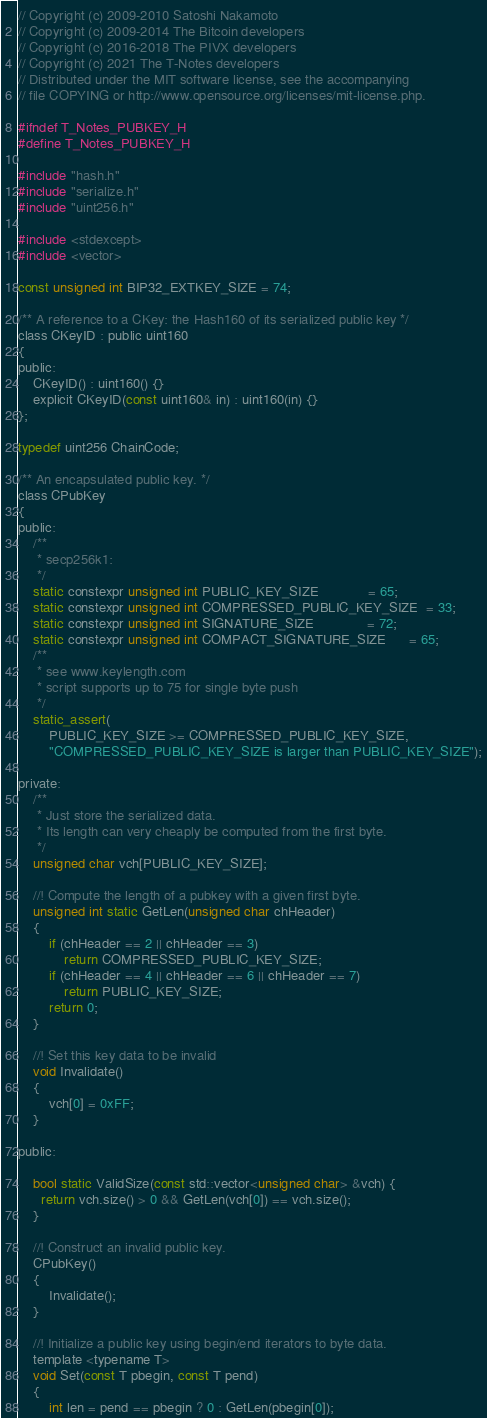<code> <loc_0><loc_0><loc_500><loc_500><_C_>// Copyright (c) 2009-2010 Satoshi Nakamoto
// Copyright (c) 2009-2014 The Bitcoin developers
// Copyright (c) 2016-2018 The PIVX developers
// Copyright (c) 2021 The T-Notes developers
// Distributed under the MIT software license, see the accompanying
// file COPYING or http://www.opensource.org/licenses/mit-license.php.

#ifndef T_Notes_PUBKEY_H
#define T_Notes_PUBKEY_H

#include "hash.h"
#include "serialize.h"
#include "uint256.h"

#include <stdexcept>
#include <vector>

const unsigned int BIP32_EXTKEY_SIZE = 74;

/** A reference to a CKey: the Hash160 of its serialized public key */
class CKeyID : public uint160
{
public:
    CKeyID() : uint160() {}
    explicit CKeyID(const uint160& in) : uint160(in) {}
};

typedef uint256 ChainCode;

/** An encapsulated public key. */
class CPubKey
{
public:
    /**
     * secp256k1:
     */
    static constexpr unsigned int PUBLIC_KEY_SIZE             = 65;
    static constexpr unsigned int COMPRESSED_PUBLIC_KEY_SIZE  = 33;
    static constexpr unsigned int SIGNATURE_SIZE              = 72;
    static constexpr unsigned int COMPACT_SIGNATURE_SIZE      = 65;
    /**
     * see www.keylength.com
     * script supports up to 75 for single byte push
     */
    static_assert(
        PUBLIC_KEY_SIZE >= COMPRESSED_PUBLIC_KEY_SIZE,
        "COMPRESSED_PUBLIC_KEY_SIZE is larger than PUBLIC_KEY_SIZE");

private:
    /**
     * Just store the serialized data.
     * Its length can very cheaply be computed from the first byte.
     */
    unsigned char vch[PUBLIC_KEY_SIZE];

    //! Compute the length of a pubkey with a given first byte.
    unsigned int static GetLen(unsigned char chHeader)
    {
        if (chHeader == 2 || chHeader == 3)
            return COMPRESSED_PUBLIC_KEY_SIZE;
        if (chHeader == 4 || chHeader == 6 || chHeader == 7)
            return PUBLIC_KEY_SIZE;
        return 0;
    }

    //! Set this key data to be invalid
    void Invalidate()
    {
        vch[0] = 0xFF;
    }

public:

    bool static ValidSize(const std::vector<unsigned char> &vch) {
      return vch.size() > 0 && GetLen(vch[0]) == vch.size();
    }

    //! Construct an invalid public key.
    CPubKey()
    {
        Invalidate();
    }

    //! Initialize a public key using begin/end iterators to byte data.
    template <typename T>
    void Set(const T pbegin, const T pend)
    {
        int len = pend == pbegin ? 0 : GetLen(pbegin[0]);</code> 